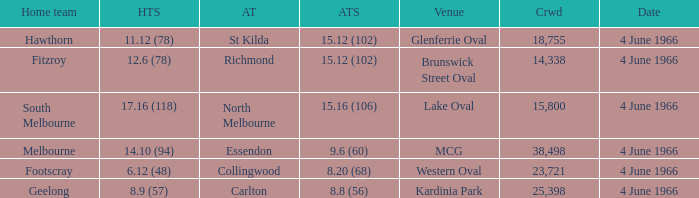What is the largest crowd size that watch a game where the home team scored 12.6 (78)? 14338.0. 